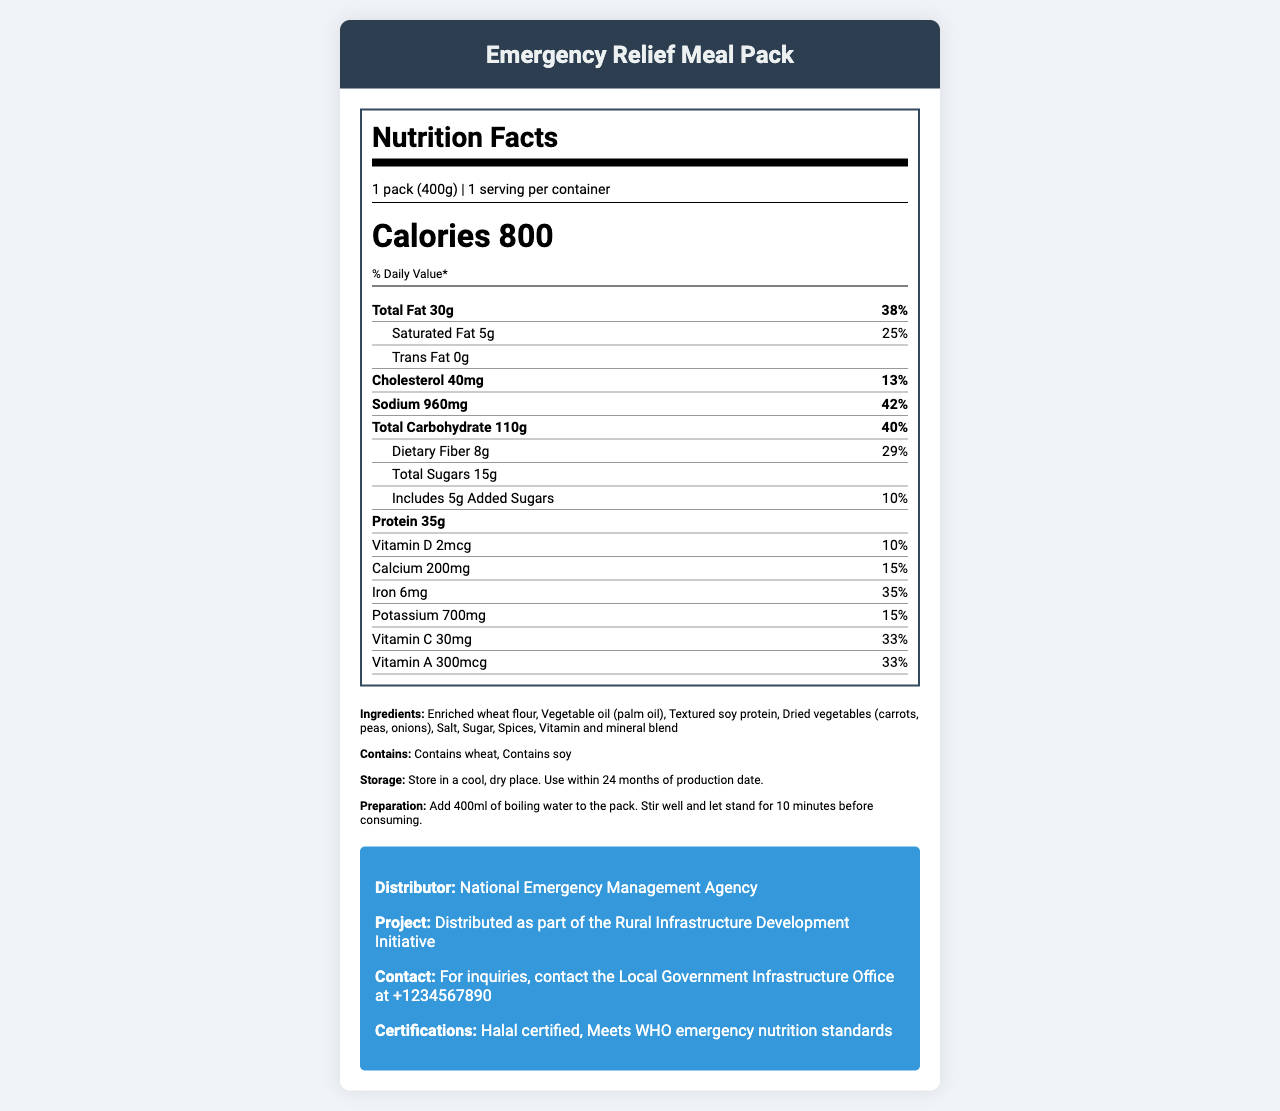What is the serving size of the Emergency Relief Meal Pack? The serving size is specified in the document as "1 pack (400g)".
Answer: 1 pack (400g) How many calories are in one serving of the Emergency Relief Meal Pack? The number of calories per serving is listed as 800 in the document.
Answer: 800 What is the percentage of daily value for total fat in the Emergency Relief Meal Pack? The document notes that the total fat amount's daily value is 38%.
Answer: 38% Does the Emergency Relief Meal Pack contain any trans fat? The document specifies that the amount of trans fat is 0g, which indicates it does not contain any trans fat.
Answer: No How should the Emergency Relief Meal Pack be prepared? The preparation instructions in the document state to add 400ml of boiling water, stir, and let stand for 10 minutes.
Answer: Add 400ml of boiling water to the pack. Stir well and let stand for 10 minutes before consuming. What are the main ingredients of the Emergency Relief Meal Pack? The document lists these ingredients in the ingredients section.
Answer: Enriched wheat flour, Vegetable oil (palm oil), Textured soy protein, Dried vegetables (carrots, peas, onions), Salt, Sugar, Spices, Vitamin and mineral blend Which allergen is present in the Emergency Relief Meal Pack? A. Dairy B. Soy C. Nuts D. Fish The allergens listed in the document are wheat and soy. Soy is the correct option here.
Answer: B What is the daily value percentage for sodium? A. 13% B. 25% C. 38% D. 42% The document states the daily value percentage for sodium is 42%.
Answer: D Is the Emergency Relief Meal Pack Halal certified? The document indicates that the product is Halal certified in the certifications section.
Answer: Yes Does the Emergency Relief Meal Pack meet WHO emergency nutrition standards? The document confirms this under certifications.
Answer: Yes Provide a brief summary of the document. The document serves as a Nutrition Facts Label for the Emergency Relief Meal Pack, offering an extensive overview of its nutritional content, preparation, storage, and distribution details.
Answer: The document provides detailed nutrition information for an Emergency Relief Meal Pack distributed by the National Emergency Management Agency. It includes the serving size, calorie count, and daily value percentages for various nutrients. Ingredients, allergens, storage, and preparation instructions are listed. Additionally, it mentions certifications and project information, indicating that the pack meets WHO emergency nutrition standards and is Halal certified. How much protein does the Emergency Relief Meal Pack contain? The document lists the protein content as 35g per serving.
Answer: 35g What is the contact information for inquiries? The document lists the contact information under the project information section.
Answer: For inquiries, contact the Local Government Infrastructure Office at +1234567890 What additional vitamins and minerals are listed, apart from the basic macronutrients? These vitamins and minerals are mentioned along with their daily value percentages in the nutrient section of the document.
Answer: Vitamin D, Vitamin C, Vitamin A, Calcium, Iron, Potassium What is the storage instruction for the Emergency Relief Meal Pack? The storage instructions provided state to keep it in a cool, dry place and use within 24 months.
Answer: Store in a cool, dry place. Use within 24 months of production date. Who is the distributor of the Emergency Relief Meal Pack? The document states that the distributor is the National Emergency Management Agency.
Answer: National Emergency Management Agency What kind of enrichment does the wheat flour in the Emergency Relief Meal Pack have? The document states the ingredient as "Enriched wheat flour" but does not provide specific details about the enrichment.
Answer: Cannot be determined What is the daily value percentage for dietary fiber? The percentage of the daily value for dietary fiber is listed as 29% in the document.
Answer: 29% 